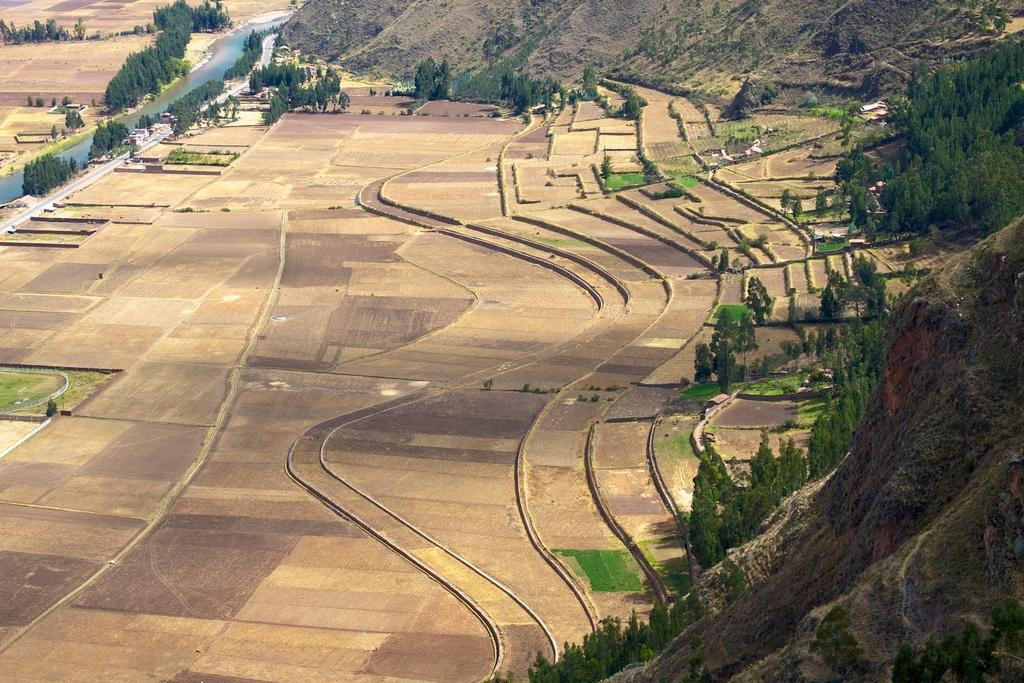What type of farming is depicted in the image? There is step farming in the image. What type of vegetation can be seen in the image? There are trees in the image. What type of infrastructure is present in the image? There is a road in the image. What type of natural feature is visible in the image? There is water visible in the image. What type of geographical feature is present in the image? There are hills in the image. How many houses are visible in the image? There are no houses visible in the image. What type of playground equipment can be seen in the image? There is no playground equipment present in the image. 